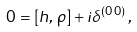Convert formula to latex. <formula><loc_0><loc_0><loc_500><loc_500>0 = \left [ h , \, \rho \right ] + i \delta ^ { ( 0 \, 0 ) } \, ,</formula> 